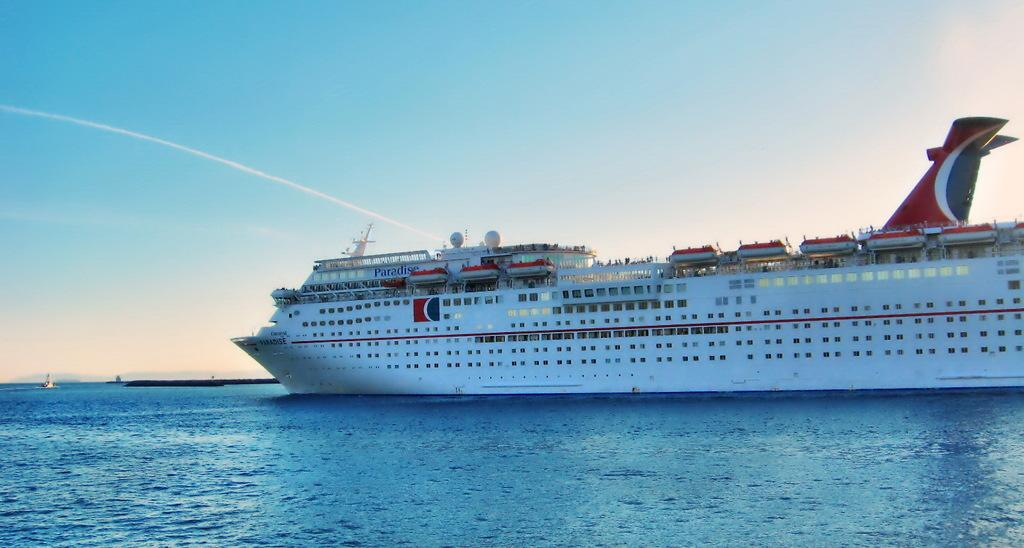<image>
Create a compact narrative representing the image presented. A large cruise ship with the word Paradise written on the side of it sails in the ocean. 